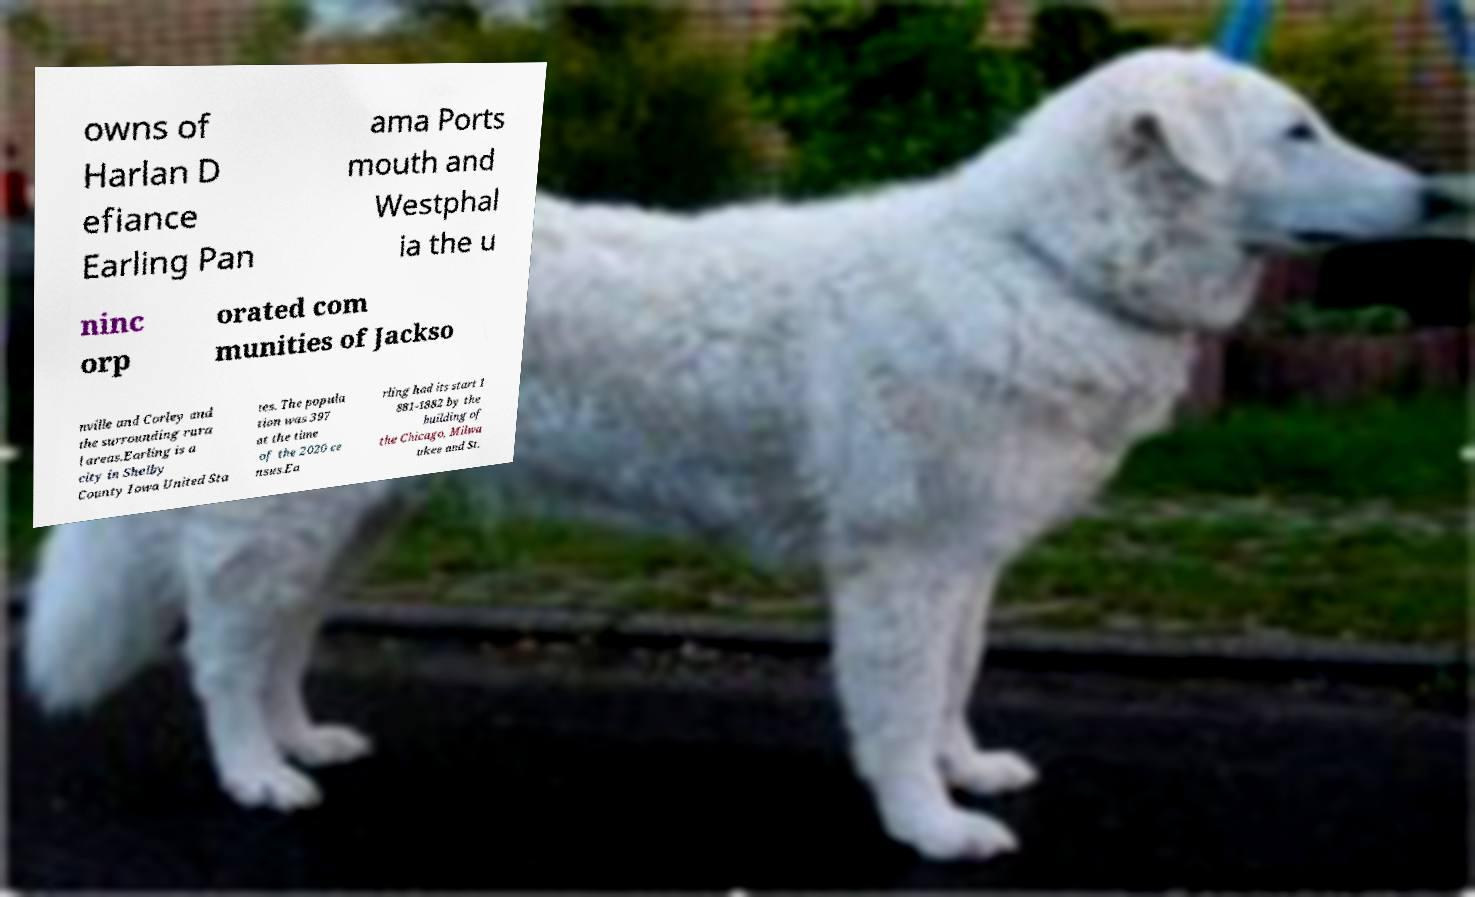What messages or text are displayed in this image? I need them in a readable, typed format. owns of Harlan D efiance Earling Pan ama Ports mouth and Westphal ia the u ninc orp orated com munities of Jackso nville and Corley and the surrounding rura l areas.Earling is a city in Shelby County Iowa United Sta tes. The popula tion was 397 at the time of the 2020 ce nsus.Ea rling had its start 1 881-1882 by the building of the Chicago, Milwa ukee and St. 